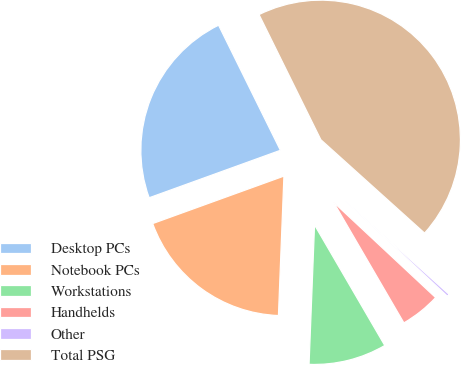Convert chart to OTSL. <chart><loc_0><loc_0><loc_500><loc_500><pie_chart><fcel>Desktop PCs<fcel>Notebook PCs<fcel>Workstations<fcel>Handhelds<fcel>Other<fcel>Total PSG<nl><fcel>23.22%<fcel>18.85%<fcel>9.02%<fcel>4.65%<fcel>0.29%<fcel>43.97%<nl></chart> 